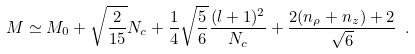<formula> <loc_0><loc_0><loc_500><loc_500>M \simeq M _ { 0 } + \sqrt { \frac { 2 } { 1 5 } } N _ { c } + \frac { 1 } { 4 } \sqrt { \frac { 5 } { 6 } } \frac { ( l + 1 ) ^ { 2 } } { N _ { c } } + \frac { 2 ( n _ { \rho } + n _ { z } ) + 2 } { \sqrt { 6 } } \ .</formula> 